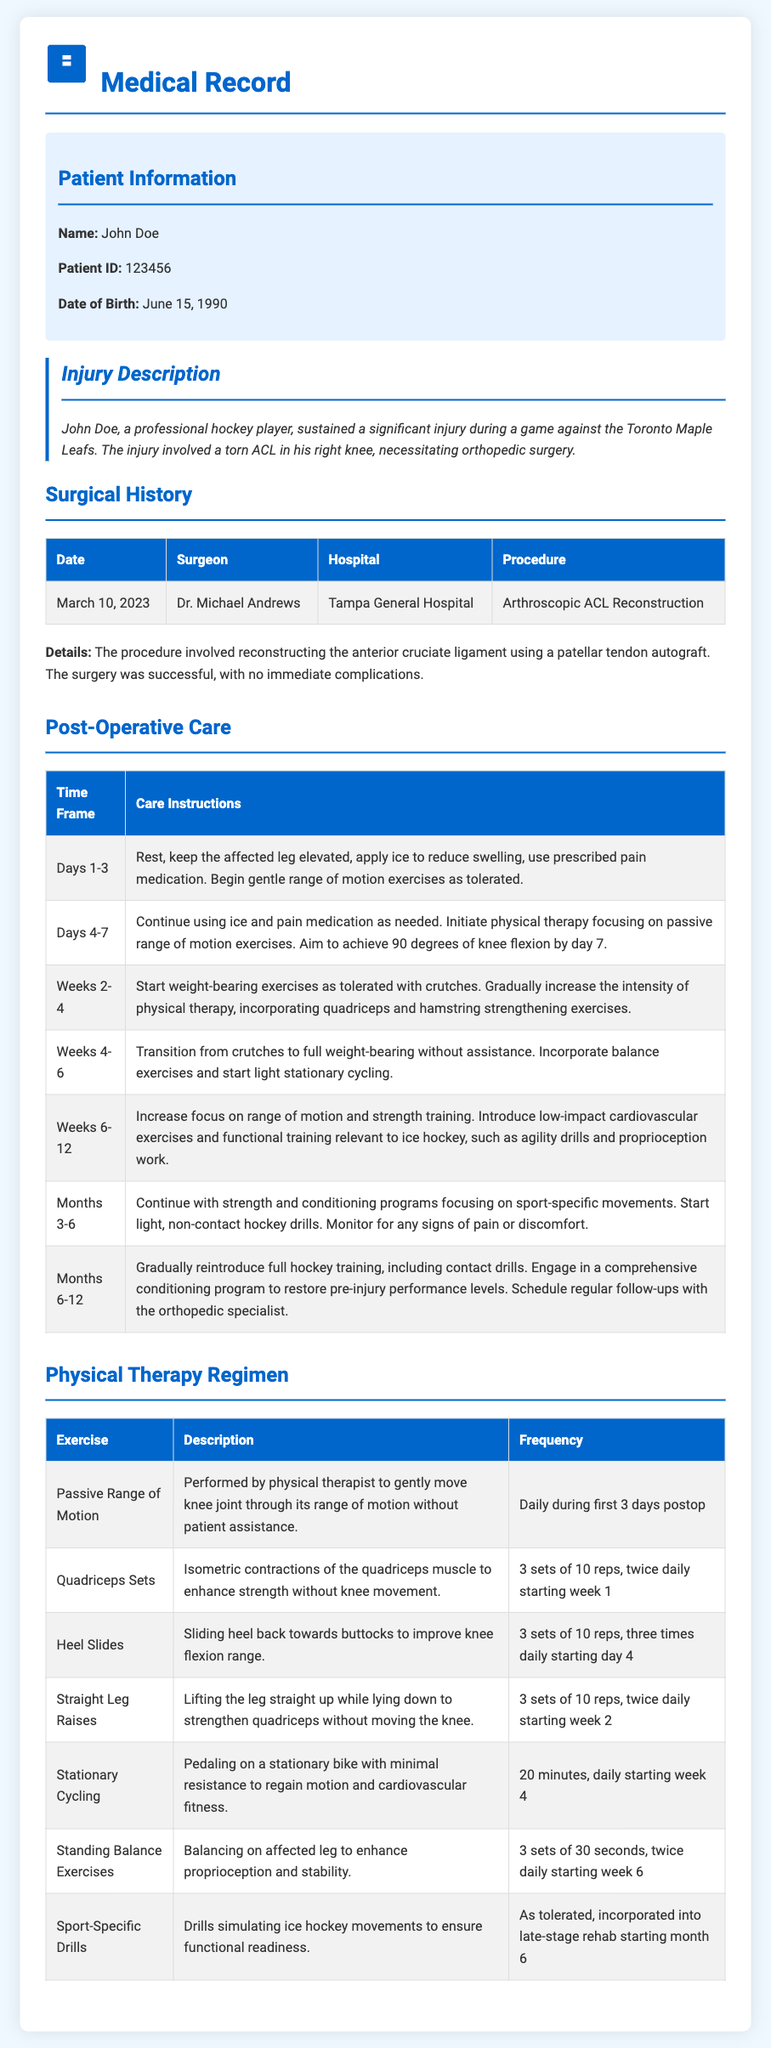What is the patient's name? The patient's name is explicitly mentioned in the document under Patient Information as John Doe.
Answer: John Doe What surgery did the patient undergo? The procedure performed on the patient is stated in the Surgical History section as Arthroscopic ACL Reconstruction.
Answer: Arthroscopic ACL Reconstruction Who was the surgeon? The name of the surgeon is provided in the Surgical History table as Dr. Michael Andrews.
Answer: Dr. Michael Andrews What is the hospital's name? The hospital where the surgery was conducted is listed in the Surgical History as Tampa General Hospital.
Answer: Tampa General Hospital On what date did the surgery take place? The date of the surgery is mentioned in the Surgical History as March 10, 2023.
Answer: March 10, 2023 What is the focus during Weeks 6-12 of post-operative care? The focus during the specified time of post-operative care is detailed in the table as increasing range of motion and strength training.
Answer: Increase range of motion and strength training How often should passive range of motion exercises be performed after surgery? The document specifies that passive range of motion exercises should be performed daily during the first 3 days post-op.
Answer: Daily during first 3 days postop What exercise is introduced starting week 4? The exercise introduced beginning in week 4 is mentioned as Stationary Cycling as part of the physical therapy regimen.
Answer: Stationary Cycling How long is the follow-up period after surgery? The post-operative care section outlines follow-up procedures, which indicates a gradual reintroduction of full hockey training by months 6-12, suggesting a total follow-up period of one year.
Answer: Months 6-12 